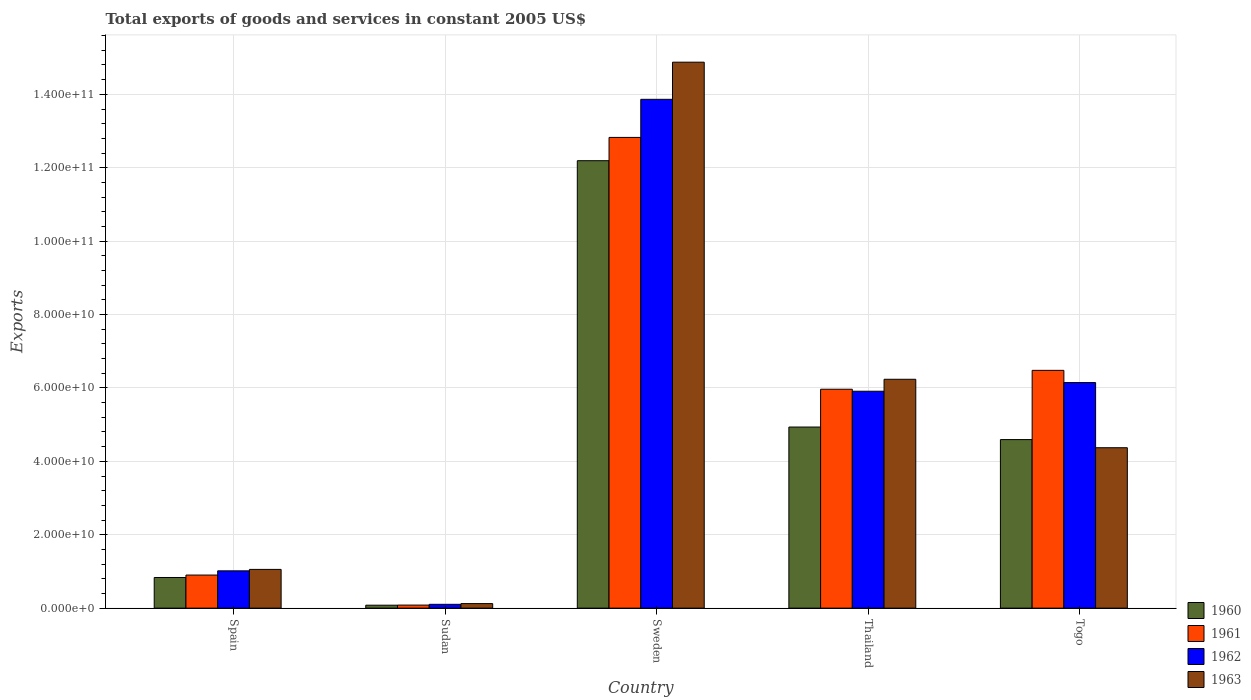How many groups of bars are there?
Provide a succinct answer. 5. Are the number of bars per tick equal to the number of legend labels?
Provide a short and direct response. Yes. How many bars are there on the 2nd tick from the right?
Provide a short and direct response. 4. In how many cases, is the number of bars for a given country not equal to the number of legend labels?
Provide a short and direct response. 0. What is the total exports of goods and services in 1962 in Togo?
Your answer should be compact. 6.15e+1. Across all countries, what is the maximum total exports of goods and services in 1962?
Provide a short and direct response. 1.39e+11. Across all countries, what is the minimum total exports of goods and services in 1960?
Offer a terse response. 8.03e+08. In which country was the total exports of goods and services in 1961 minimum?
Ensure brevity in your answer.  Sudan. What is the total total exports of goods and services in 1960 in the graph?
Offer a very short reply. 2.26e+11. What is the difference between the total exports of goods and services in 1962 in Sweden and that in Thailand?
Provide a succinct answer. 7.95e+1. What is the difference between the total exports of goods and services in 1962 in Togo and the total exports of goods and services in 1961 in Thailand?
Your response must be concise. 1.81e+09. What is the average total exports of goods and services in 1963 per country?
Your answer should be very brief. 5.33e+1. What is the difference between the total exports of goods and services of/in 1963 and total exports of goods and services of/in 1960 in Spain?
Provide a succinct answer. 2.21e+09. In how many countries, is the total exports of goods and services in 1960 greater than 152000000000 US$?
Your answer should be very brief. 0. What is the ratio of the total exports of goods and services in 1962 in Sweden to that in Thailand?
Offer a terse response. 2.35. Is the total exports of goods and services in 1961 in Thailand less than that in Togo?
Give a very brief answer. Yes. Is the difference between the total exports of goods and services in 1963 in Sudan and Togo greater than the difference between the total exports of goods and services in 1960 in Sudan and Togo?
Make the answer very short. Yes. What is the difference between the highest and the second highest total exports of goods and services in 1962?
Your response must be concise. -7.72e+1. What is the difference between the highest and the lowest total exports of goods and services in 1961?
Make the answer very short. 1.27e+11. In how many countries, is the total exports of goods and services in 1963 greater than the average total exports of goods and services in 1963 taken over all countries?
Your response must be concise. 2. Is the sum of the total exports of goods and services in 1962 in Spain and Sudan greater than the maximum total exports of goods and services in 1960 across all countries?
Offer a terse response. No. Is it the case that in every country, the sum of the total exports of goods and services in 1963 and total exports of goods and services in 1961 is greater than the total exports of goods and services in 1962?
Provide a short and direct response. Yes. Are all the bars in the graph horizontal?
Your answer should be compact. No. What is the difference between two consecutive major ticks on the Y-axis?
Offer a terse response. 2.00e+1. Does the graph contain any zero values?
Ensure brevity in your answer.  No. How many legend labels are there?
Give a very brief answer. 4. How are the legend labels stacked?
Your response must be concise. Vertical. What is the title of the graph?
Offer a terse response. Total exports of goods and services in constant 2005 US$. Does "1980" appear as one of the legend labels in the graph?
Provide a succinct answer. No. What is the label or title of the Y-axis?
Your response must be concise. Exports. What is the Exports in 1960 in Spain?
Give a very brief answer. 8.35e+09. What is the Exports in 1961 in Spain?
Your response must be concise. 9.02e+09. What is the Exports in 1962 in Spain?
Provide a succinct answer. 1.02e+1. What is the Exports in 1963 in Spain?
Give a very brief answer. 1.06e+1. What is the Exports in 1960 in Sudan?
Provide a short and direct response. 8.03e+08. What is the Exports in 1961 in Sudan?
Your response must be concise. 8.33e+08. What is the Exports of 1962 in Sudan?
Give a very brief answer. 1.04e+09. What is the Exports in 1963 in Sudan?
Your answer should be compact. 1.24e+09. What is the Exports of 1960 in Sweden?
Make the answer very short. 1.22e+11. What is the Exports in 1961 in Sweden?
Ensure brevity in your answer.  1.28e+11. What is the Exports in 1962 in Sweden?
Provide a succinct answer. 1.39e+11. What is the Exports of 1963 in Sweden?
Provide a succinct answer. 1.49e+11. What is the Exports in 1960 in Thailand?
Ensure brevity in your answer.  4.93e+1. What is the Exports in 1961 in Thailand?
Provide a succinct answer. 5.97e+1. What is the Exports of 1962 in Thailand?
Your answer should be compact. 5.91e+1. What is the Exports of 1963 in Thailand?
Ensure brevity in your answer.  6.24e+1. What is the Exports of 1960 in Togo?
Your answer should be very brief. 4.59e+1. What is the Exports in 1961 in Togo?
Your answer should be compact. 6.48e+1. What is the Exports of 1962 in Togo?
Provide a short and direct response. 6.15e+1. What is the Exports in 1963 in Togo?
Provide a succinct answer. 4.37e+1. Across all countries, what is the maximum Exports in 1960?
Ensure brevity in your answer.  1.22e+11. Across all countries, what is the maximum Exports of 1961?
Ensure brevity in your answer.  1.28e+11. Across all countries, what is the maximum Exports of 1962?
Your response must be concise. 1.39e+11. Across all countries, what is the maximum Exports of 1963?
Ensure brevity in your answer.  1.49e+11. Across all countries, what is the minimum Exports of 1960?
Your response must be concise. 8.03e+08. Across all countries, what is the minimum Exports in 1961?
Provide a succinct answer. 8.33e+08. Across all countries, what is the minimum Exports of 1962?
Keep it short and to the point. 1.04e+09. Across all countries, what is the minimum Exports of 1963?
Offer a very short reply. 1.24e+09. What is the total Exports of 1960 in the graph?
Your answer should be compact. 2.26e+11. What is the total Exports in 1961 in the graph?
Offer a very short reply. 2.63e+11. What is the total Exports in 1962 in the graph?
Provide a short and direct response. 2.70e+11. What is the total Exports in 1963 in the graph?
Offer a terse response. 2.67e+11. What is the difference between the Exports of 1960 in Spain and that in Sudan?
Provide a short and direct response. 7.55e+09. What is the difference between the Exports of 1961 in Spain and that in Sudan?
Your answer should be very brief. 8.18e+09. What is the difference between the Exports in 1962 in Spain and that in Sudan?
Your answer should be compact. 9.12e+09. What is the difference between the Exports of 1963 in Spain and that in Sudan?
Keep it short and to the point. 9.32e+09. What is the difference between the Exports of 1960 in Spain and that in Sweden?
Your answer should be very brief. -1.14e+11. What is the difference between the Exports in 1961 in Spain and that in Sweden?
Offer a terse response. -1.19e+11. What is the difference between the Exports in 1962 in Spain and that in Sweden?
Keep it short and to the point. -1.28e+11. What is the difference between the Exports in 1963 in Spain and that in Sweden?
Your answer should be very brief. -1.38e+11. What is the difference between the Exports of 1960 in Spain and that in Thailand?
Ensure brevity in your answer.  -4.10e+1. What is the difference between the Exports in 1961 in Spain and that in Thailand?
Give a very brief answer. -5.06e+1. What is the difference between the Exports of 1962 in Spain and that in Thailand?
Ensure brevity in your answer.  -4.89e+1. What is the difference between the Exports of 1963 in Spain and that in Thailand?
Provide a short and direct response. -5.18e+1. What is the difference between the Exports in 1960 in Spain and that in Togo?
Provide a short and direct response. -3.76e+1. What is the difference between the Exports in 1961 in Spain and that in Togo?
Give a very brief answer. -5.58e+1. What is the difference between the Exports of 1962 in Spain and that in Togo?
Provide a succinct answer. -5.13e+1. What is the difference between the Exports in 1963 in Spain and that in Togo?
Ensure brevity in your answer.  -3.32e+1. What is the difference between the Exports in 1960 in Sudan and that in Sweden?
Your answer should be very brief. -1.21e+11. What is the difference between the Exports in 1961 in Sudan and that in Sweden?
Provide a succinct answer. -1.27e+11. What is the difference between the Exports of 1962 in Sudan and that in Sweden?
Offer a very short reply. -1.38e+11. What is the difference between the Exports of 1963 in Sudan and that in Sweden?
Give a very brief answer. -1.48e+11. What is the difference between the Exports of 1960 in Sudan and that in Thailand?
Your response must be concise. -4.85e+1. What is the difference between the Exports of 1961 in Sudan and that in Thailand?
Offer a terse response. -5.88e+1. What is the difference between the Exports in 1962 in Sudan and that in Thailand?
Your answer should be very brief. -5.81e+1. What is the difference between the Exports in 1963 in Sudan and that in Thailand?
Give a very brief answer. -6.11e+1. What is the difference between the Exports in 1960 in Sudan and that in Togo?
Offer a very short reply. -4.51e+1. What is the difference between the Exports in 1961 in Sudan and that in Togo?
Your answer should be compact. -6.40e+1. What is the difference between the Exports of 1962 in Sudan and that in Togo?
Offer a very short reply. -6.04e+1. What is the difference between the Exports of 1963 in Sudan and that in Togo?
Offer a terse response. -4.25e+1. What is the difference between the Exports of 1960 in Sweden and that in Thailand?
Your answer should be compact. 7.26e+1. What is the difference between the Exports of 1961 in Sweden and that in Thailand?
Provide a short and direct response. 6.86e+1. What is the difference between the Exports in 1962 in Sweden and that in Thailand?
Offer a very short reply. 7.95e+1. What is the difference between the Exports in 1963 in Sweden and that in Thailand?
Provide a short and direct response. 8.64e+1. What is the difference between the Exports of 1960 in Sweden and that in Togo?
Keep it short and to the point. 7.60e+1. What is the difference between the Exports in 1961 in Sweden and that in Togo?
Keep it short and to the point. 6.35e+1. What is the difference between the Exports of 1962 in Sweden and that in Togo?
Offer a very short reply. 7.72e+1. What is the difference between the Exports in 1963 in Sweden and that in Togo?
Your answer should be very brief. 1.05e+11. What is the difference between the Exports of 1960 in Thailand and that in Togo?
Offer a very short reply. 3.42e+09. What is the difference between the Exports in 1961 in Thailand and that in Togo?
Keep it short and to the point. -5.14e+09. What is the difference between the Exports of 1962 in Thailand and that in Togo?
Provide a short and direct response. -2.36e+09. What is the difference between the Exports in 1963 in Thailand and that in Togo?
Ensure brevity in your answer.  1.87e+1. What is the difference between the Exports of 1960 in Spain and the Exports of 1961 in Sudan?
Make the answer very short. 7.52e+09. What is the difference between the Exports in 1960 in Spain and the Exports in 1962 in Sudan?
Ensure brevity in your answer.  7.31e+09. What is the difference between the Exports of 1960 in Spain and the Exports of 1963 in Sudan?
Offer a very short reply. 7.11e+09. What is the difference between the Exports in 1961 in Spain and the Exports in 1962 in Sudan?
Your answer should be compact. 7.97e+09. What is the difference between the Exports of 1961 in Spain and the Exports of 1963 in Sudan?
Your response must be concise. 7.78e+09. What is the difference between the Exports of 1962 in Spain and the Exports of 1963 in Sudan?
Your response must be concise. 8.93e+09. What is the difference between the Exports in 1960 in Spain and the Exports in 1961 in Sweden?
Ensure brevity in your answer.  -1.20e+11. What is the difference between the Exports of 1960 in Spain and the Exports of 1962 in Sweden?
Offer a terse response. -1.30e+11. What is the difference between the Exports of 1960 in Spain and the Exports of 1963 in Sweden?
Provide a short and direct response. -1.40e+11. What is the difference between the Exports in 1961 in Spain and the Exports in 1962 in Sweden?
Your answer should be compact. -1.30e+11. What is the difference between the Exports in 1961 in Spain and the Exports in 1963 in Sweden?
Offer a very short reply. -1.40e+11. What is the difference between the Exports of 1962 in Spain and the Exports of 1963 in Sweden?
Provide a succinct answer. -1.39e+11. What is the difference between the Exports in 1960 in Spain and the Exports in 1961 in Thailand?
Offer a very short reply. -5.13e+1. What is the difference between the Exports of 1960 in Spain and the Exports of 1962 in Thailand?
Offer a terse response. -5.08e+1. What is the difference between the Exports in 1960 in Spain and the Exports in 1963 in Thailand?
Give a very brief answer. -5.40e+1. What is the difference between the Exports in 1961 in Spain and the Exports in 1962 in Thailand?
Provide a succinct answer. -5.01e+1. What is the difference between the Exports of 1961 in Spain and the Exports of 1963 in Thailand?
Give a very brief answer. -5.33e+1. What is the difference between the Exports of 1962 in Spain and the Exports of 1963 in Thailand?
Keep it short and to the point. -5.22e+1. What is the difference between the Exports of 1960 in Spain and the Exports of 1961 in Togo?
Your response must be concise. -5.64e+1. What is the difference between the Exports of 1960 in Spain and the Exports of 1962 in Togo?
Provide a short and direct response. -5.31e+1. What is the difference between the Exports of 1960 in Spain and the Exports of 1963 in Togo?
Offer a very short reply. -3.54e+1. What is the difference between the Exports in 1961 in Spain and the Exports in 1962 in Togo?
Provide a succinct answer. -5.24e+1. What is the difference between the Exports of 1961 in Spain and the Exports of 1963 in Togo?
Offer a very short reply. -3.47e+1. What is the difference between the Exports in 1962 in Spain and the Exports in 1963 in Togo?
Your answer should be compact. -3.35e+1. What is the difference between the Exports of 1960 in Sudan and the Exports of 1961 in Sweden?
Provide a short and direct response. -1.27e+11. What is the difference between the Exports in 1960 in Sudan and the Exports in 1962 in Sweden?
Give a very brief answer. -1.38e+11. What is the difference between the Exports of 1960 in Sudan and the Exports of 1963 in Sweden?
Keep it short and to the point. -1.48e+11. What is the difference between the Exports in 1961 in Sudan and the Exports in 1962 in Sweden?
Ensure brevity in your answer.  -1.38e+11. What is the difference between the Exports of 1961 in Sudan and the Exports of 1963 in Sweden?
Offer a very short reply. -1.48e+11. What is the difference between the Exports of 1962 in Sudan and the Exports of 1963 in Sweden?
Offer a terse response. -1.48e+11. What is the difference between the Exports in 1960 in Sudan and the Exports in 1961 in Thailand?
Provide a short and direct response. -5.88e+1. What is the difference between the Exports of 1960 in Sudan and the Exports of 1962 in Thailand?
Ensure brevity in your answer.  -5.83e+1. What is the difference between the Exports of 1960 in Sudan and the Exports of 1963 in Thailand?
Offer a very short reply. -6.16e+1. What is the difference between the Exports of 1961 in Sudan and the Exports of 1962 in Thailand?
Provide a short and direct response. -5.83e+1. What is the difference between the Exports of 1961 in Sudan and the Exports of 1963 in Thailand?
Offer a terse response. -6.15e+1. What is the difference between the Exports of 1962 in Sudan and the Exports of 1963 in Thailand?
Provide a succinct answer. -6.13e+1. What is the difference between the Exports of 1960 in Sudan and the Exports of 1961 in Togo?
Offer a very short reply. -6.40e+1. What is the difference between the Exports of 1960 in Sudan and the Exports of 1962 in Togo?
Provide a succinct answer. -6.07e+1. What is the difference between the Exports of 1960 in Sudan and the Exports of 1963 in Togo?
Ensure brevity in your answer.  -4.29e+1. What is the difference between the Exports in 1961 in Sudan and the Exports in 1962 in Togo?
Offer a terse response. -6.06e+1. What is the difference between the Exports in 1961 in Sudan and the Exports in 1963 in Togo?
Keep it short and to the point. -4.29e+1. What is the difference between the Exports of 1962 in Sudan and the Exports of 1963 in Togo?
Offer a very short reply. -4.27e+1. What is the difference between the Exports of 1960 in Sweden and the Exports of 1961 in Thailand?
Keep it short and to the point. 6.23e+1. What is the difference between the Exports in 1960 in Sweden and the Exports in 1962 in Thailand?
Offer a very short reply. 6.28e+1. What is the difference between the Exports in 1960 in Sweden and the Exports in 1963 in Thailand?
Your answer should be compact. 5.96e+1. What is the difference between the Exports of 1961 in Sweden and the Exports of 1962 in Thailand?
Your response must be concise. 6.92e+1. What is the difference between the Exports in 1961 in Sweden and the Exports in 1963 in Thailand?
Provide a succinct answer. 6.59e+1. What is the difference between the Exports of 1962 in Sweden and the Exports of 1963 in Thailand?
Your answer should be compact. 7.63e+1. What is the difference between the Exports of 1960 in Sweden and the Exports of 1961 in Togo?
Provide a succinct answer. 5.71e+1. What is the difference between the Exports of 1960 in Sweden and the Exports of 1962 in Togo?
Provide a short and direct response. 6.05e+1. What is the difference between the Exports in 1960 in Sweden and the Exports in 1963 in Togo?
Offer a terse response. 7.82e+1. What is the difference between the Exports of 1961 in Sweden and the Exports of 1962 in Togo?
Offer a very short reply. 6.68e+1. What is the difference between the Exports of 1961 in Sweden and the Exports of 1963 in Togo?
Your response must be concise. 8.46e+1. What is the difference between the Exports in 1962 in Sweden and the Exports in 1963 in Togo?
Make the answer very short. 9.49e+1. What is the difference between the Exports in 1960 in Thailand and the Exports in 1961 in Togo?
Your response must be concise. -1.54e+1. What is the difference between the Exports in 1960 in Thailand and the Exports in 1962 in Togo?
Provide a short and direct response. -1.21e+1. What is the difference between the Exports in 1960 in Thailand and the Exports in 1963 in Togo?
Offer a terse response. 5.64e+09. What is the difference between the Exports in 1961 in Thailand and the Exports in 1962 in Togo?
Offer a terse response. -1.81e+09. What is the difference between the Exports in 1961 in Thailand and the Exports in 1963 in Togo?
Provide a succinct answer. 1.59e+1. What is the difference between the Exports in 1962 in Thailand and the Exports in 1963 in Togo?
Give a very brief answer. 1.54e+1. What is the average Exports of 1960 per country?
Ensure brevity in your answer.  4.53e+1. What is the average Exports of 1961 per country?
Offer a terse response. 5.25e+1. What is the average Exports of 1962 per country?
Ensure brevity in your answer.  5.41e+1. What is the average Exports in 1963 per country?
Your response must be concise. 5.33e+1. What is the difference between the Exports in 1960 and Exports in 1961 in Spain?
Make the answer very short. -6.64e+08. What is the difference between the Exports in 1960 and Exports in 1962 in Spain?
Offer a terse response. -1.82e+09. What is the difference between the Exports of 1960 and Exports of 1963 in Spain?
Your answer should be compact. -2.21e+09. What is the difference between the Exports in 1961 and Exports in 1962 in Spain?
Offer a terse response. -1.15e+09. What is the difference between the Exports of 1961 and Exports of 1963 in Spain?
Provide a short and direct response. -1.54e+09. What is the difference between the Exports of 1962 and Exports of 1963 in Spain?
Offer a terse response. -3.90e+08. What is the difference between the Exports in 1960 and Exports in 1961 in Sudan?
Ensure brevity in your answer.  -3.01e+07. What is the difference between the Exports of 1960 and Exports of 1962 in Sudan?
Make the answer very short. -2.41e+08. What is the difference between the Exports of 1960 and Exports of 1963 in Sudan?
Provide a succinct answer. -4.34e+08. What is the difference between the Exports of 1961 and Exports of 1962 in Sudan?
Keep it short and to the point. -2.11e+08. What is the difference between the Exports in 1961 and Exports in 1963 in Sudan?
Offer a terse response. -4.04e+08. What is the difference between the Exports in 1962 and Exports in 1963 in Sudan?
Keep it short and to the point. -1.93e+08. What is the difference between the Exports in 1960 and Exports in 1961 in Sweden?
Ensure brevity in your answer.  -6.34e+09. What is the difference between the Exports of 1960 and Exports of 1962 in Sweden?
Provide a succinct answer. -1.67e+1. What is the difference between the Exports of 1960 and Exports of 1963 in Sweden?
Provide a short and direct response. -2.68e+1. What is the difference between the Exports in 1961 and Exports in 1962 in Sweden?
Your response must be concise. -1.04e+1. What is the difference between the Exports in 1961 and Exports in 1963 in Sweden?
Ensure brevity in your answer.  -2.05e+1. What is the difference between the Exports of 1962 and Exports of 1963 in Sweden?
Provide a succinct answer. -1.01e+1. What is the difference between the Exports of 1960 and Exports of 1961 in Thailand?
Offer a very short reply. -1.03e+1. What is the difference between the Exports of 1960 and Exports of 1962 in Thailand?
Make the answer very short. -9.76e+09. What is the difference between the Exports in 1960 and Exports in 1963 in Thailand?
Offer a very short reply. -1.30e+1. What is the difference between the Exports in 1961 and Exports in 1962 in Thailand?
Your response must be concise. 5.43e+08. What is the difference between the Exports of 1961 and Exports of 1963 in Thailand?
Your answer should be compact. -2.71e+09. What is the difference between the Exports in 1962 and Exports in 1963 in Thailand?
Your answer should be very brief. -3.25e+09. What is the difference between the Exports in 1960 and Exports in 1961 in Togo?
Your answer should be compact. -1.89e+1. What is the difference between the Exports in 1960 and Exports in 1962 in Togo?
Your answer should be compact. -1.55e+1. What is the difference between the Exports of 1960 and Exports of 1963 in Togo?
Your answer should be compact. 2.22e+09. What is the difference between the Exports in 1961 and Exports in 1962 in Togo?
Offer a terse response. 3.33e+09. What is the difference between the Exports of 1961 and Exports of 1963 in Togo?
Offer a very short reply. 2.11e+1. What is the difference between the Exports of 1962 and Exports of 1963 in Togo?
Your answer should be very brief. 1.78e+1. What is the ratio of the Exports of 1960 in Spain to that in Sudan?
Your response must be concise. 10.41. What is the ratio of the Exports in 1961 in Spain to that in Sudan?
Give a very brief answer. 10.83. What is the ratio of the Exports of 1962 in Spain to that in Sudan?
Ensure brevity in your answer.  9.74. What is the ratio of the Exports of 1963 in Spain to that in Sudan?
Provide a short and direct response. 8.54. What is the ratio of the Exports of 1960 in Spain to that in Sweden?
Give a very brief answer. 0.07. What is the ratio of the Exports of 1961 in Spain to that in Sweden?
Provide a short and direct response. 0.07. What is the ratio of the Exports of 1962 in Spain to that in Sweden?
Your answer should be compact. 0.07. What is the ratio of the Exports of 1963 in Spain to that in Sweden?
Keep it short and to the point. 0.07. What is the ratio of the Exports in 1960 in Spain to that in Thailand?
Give a very brief answer. 0.17. What is the ratio of the Exports in 1961 in Spain to that in Thailand?
Ensure brevity in your answer.  0.15. What is the ratio of the Exports of 1962 in Spain to that in Thailand?
Your answer should be very brief. 0.17. What is the ratio of the Exports of 1963 in Spain to that in Thailand?
Give a very brief answer. 0.17. What is the ratio of the Exports of 1960 in Spain to that in Togo?
Give a very brief answer. 0.18. What is the ratio of the Exports of 1961 in Spain to that in Togo?
Provide a succinct answer. 0.14. What is the ratio of the Exports in 1962 in Spain to that in Togo?
Your response must be concise. 0.17. What is the ratio of the Exports of 1963 in Spain to that in Togo?
Ensure brevity in your answer.  0.24. What is the ratio of the Exports of 1960 in Sudan to that in Sweden?
Your answer should be very brief. 0.01. What is the ratio of the Exports in 1961 in Sudan to that in Sweden?
Your answer should be compact. 0.01. What is the ratio of the Exports of 1962 in Sudan to that in Sweden?
Offer a terse response. 0.01. What is the ratio of the Exports in 1963 in Sudan to that in Sweden?
Ensure brevity in your answer.  0.01. What is the ratio of the Exports in 1960 in Sudan to that in Thailand?
Offer a terse response. 0.02. What is the ratio of the Exports of 1961 in Sudan to that in Thailand?
Your answer should be very brief. 0.01. What is the ratio of the Exports of 1962 in Sudan to that in Thailand?
Provide a short and direct response. 0.02. What is the ratio of the Exports in 1963 in Sudan to that in Thailand?
Keep it short and to the point. 0.02. What is the ratio of the Exports in 1960 in Sudan to that in Togo?
Keep it short and to the point. 0.02. What is the ratio of the Exports in 1961 in Sudan to that in Togo?
Provide a short and direct response. 0.01. What is the ratio of the Exports of 1962 in Sudan to that in Togo?
Your answer should be compact. 0.02. What is the ratio of the Exports in 1963 in Sudan to that in Togo?
Offer a very short reply. 0.03. What is the ratio of the Exports of 1960 in Sweden to that in Thailand?
Your response must be concise. 2.47. What is the ratio of the Exports in 1961 in Sweden to that in Thailand?
Your response must be concise. 2.15. What is the ratio of the Exports of 1962 in Sweden to that in Thailand?
Offer a terse response. 2.35. What is the ratio of the Exports of 1963 in Sweden to that in Thailand?
Make the answer very short. 2.39. What is the ratio of the Exports of 1960 in Sweden to that in Togo?
Offer a terse response. 2.65. What is the ratio of the Exports of 1961 in Sweden to that in Togo?
Keep it short and to the point. 1.98. What is the ratio of the Exports of 1962 in Sweden to that in Togo?
Your answer should be compact. 2.26. What is the ratio of the Exports in 1963 in Sweden to that in Togo?
Offer a very short reply. 3.4. What is the ratio of the Exports of 1960 in Thailand to that in Togo?
Keep it short and to the point. 1.07. What is the ratio of the Exports of 1961 in Thailand to that in Togo?
Give a very brief answer. 0.92. What is the ratio of the Exports in 1962 in Thailand to that in Togo?
Your response must be concise. 0.96. What is the ratio of the Exports of 1963 in Thailand to that in Togo?
Your answer should be very brief. 1.43. What is the difference between the highest and the second highest Exports in 1960?
Provide a short and direct response. 7.26e+1. What is the difference between the highest and the second highest Exports of 1961?
Offer a very short reply. 6.35e+1. What is the difference between the highest and the second highest Exports of 1962?
Ensure brevity in your answer.  7.72e+1. What is the difference between the highest and the second highest Exports of 1963?
Provide a succinct answer. 8.64e+1. What is the difference between the highest and the lowest Exports of 1960?
Provide a succinct answer. 1.21e+11. What is the difference between the highest and the lowest Exports of 1961?
Your response must be concise. 1.27e+11. What is the difference between the highest and the lowest Exports in 1962?
Offer a terse response. 1.38e+11. What is the difference between the highest and the lowest Exports in 1963?
Your response must be concise. 1.48e+11. 